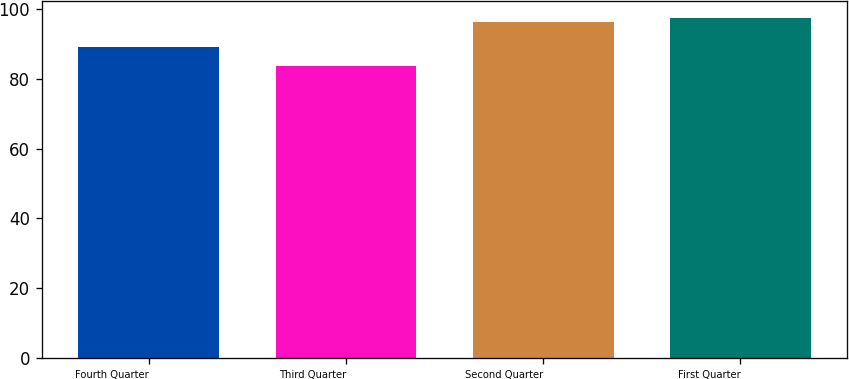Convert chart. <chart><loc_0><loc_0><loc_500><loc_500><bar_chart><fcel>Fourth Quarter<fcel>Third Quarter<fcel>Second Quarter<fcel>First Quarter<nl><fcel>88.98<fcel>83.73<fcel>96.13<fcel>97.48<nl></chart> 